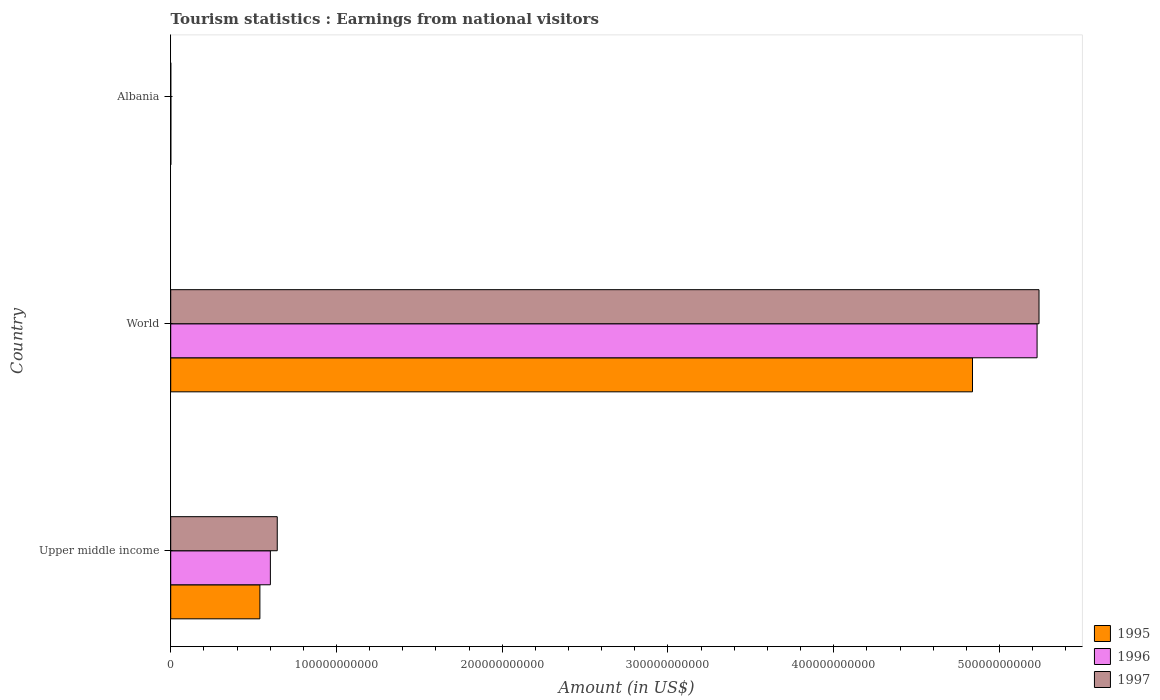Are the number of bars per tick equal to the number of legend labels?
Provide a short and direct response. Yes. Are the number of bars on each tick of the Y-axis equal?
Keep it short and to the point. Yes. How many bars are there on the 2nd tick from the bottom?
Your answer should be very brief. 3. What is the label of the 3rd group of bars from the top?
Provide a short and direct response. Upper middle income. What is the earnings from national visitors in 1997 in World?
Offer a very short reply. 5.24e+11. Across all countries, what is the maximum earnings from national visitors in 1995?
Your response must be concise. 4.84e+11. Across all countries, what is the minimum earnings from national visitors in 1995?
Offer a terse response. 7.04e+07. In which country was the earnings from national visitors in 1995 minimum?
Provide a short and direct response. Albania. What is the total earnings from national visitors in 1996 in the graph?
Keep it short and to the point. 5.83e+11. What is the difference between the earnings from national visitors in 1995 in Upper middle income and that in World?
Offer a terse response. -4.30e+11. What is the difference between the earnings from national visitors in 1995 in Upper middle income and the earnings from national visitors in 1997 in World?
Offer a terse response. -4.70e+11. What is the average earnings from national visitors in 1995 per country?
Offer a terse response. 1.79e+11. What is the difference between the earnings from national visitors in 1997 and earnings from national visitors in 1995 in Albania?
Your answer should be very brief. -3.68e+07. What is the ratio of the earnings from national visitors in 1995 in Albania to that in Upper middle income?
Ensure brevity in your answer.  0. Is the earnings from national visitors in 1995 in Albania less than that in Upper middle income?
Offer a terse response. Yes. Is the difference between the earnings from national visitors in 1997 in Upper middle income and World greater than the difference between the earnings from national visitors in 1995 in Upper middle income and World?
Keep it short and to the point. No. What is the difference between the highest and the second highest earnings from national visitors in 1997?
Your answer should be compact. 4.60e+11. What is the difference between the highest and the lowest earnings from national visitors in 1996?
Your answer should be compact. 5.23e+11. What does the 2nd bar from the bottom in Upper middle income represents?
Keep it short and to the point. 1996. Is it the case that in every country, the sum of the earnings from national visitors in 1995 and earnings from national visitors in 1996 is greater than the earnings from national visitors in 1997?
Provide a short and direct response. Yes. Are all the bars in the graph horizontal?
Make the answer very short. Yes. How many countries are there in the graph?
Your answer should be compact. 3. What is the difference between two consecutive major ticks on the X-axis?
Offer a very short reply. 1.00e+11. Does the graph contain any zero values?
Your answer should be compact. No. Does the graph contain grids?
Provide a succinct answer. No. How many legend labels are there?
Provide a succinct answer. 3. What is the title of the graph?
Keep it short and to the point. Tourism statistics : Earnings from national visitors. What is the Amount (in US$) of 1995 in Upper middle income?
Offer a very short reply. 5.38e+1. What is the Amount (in US$) in 1996 in Upper middle income?
Keep it short and to the point. 6.01e+1. What is the Amount (in US$) of 1997 in Upper middle income?
Make the answer very short. 6.43e+1. What is the Amount (in US$) of 1995 in World?
Give a very brief answer. 4.84e+11. What is the Amount (in US$) of 1996 in World?
Keep it short and to the point. 5.23e+11. What is the Amount (in US$) of 1997 in World?
Your response must be concise. 5.24e+11. What is the Amount (in US$) of 1995 in Albania?
Keep it short and to the point. 7.04e+07. What is the Amount (in US$) in 1996 in Albania?
Ensure brevity in your answer.  9.38e+07. What is the Amount (in US$) in 1997 in Albania?
Provide a short and direct response. 3.36e+07. Across all countries, what is the maximum Amount (in US$) in 1995?
Provide a short and direct response. 4.84e+11. Across all countries, what is the maximum Amount (in US$) of 1996?
Make the answer very short. 5.23e+11. Across all countries, what is the maximum Amount (in US$) of 1997?
Keep it short and to the point. 5.24e+11. Across all countries, what is the minimum Amount (in US$) of 1995?
Your response must be concise. 7.04e+07. Across all countries, what is the minimum Amount (in US$) of 1996?
Your answer should be very brief. 9.38e+07. Across all countries, what is the minimum Amount (in US$) in 1997?
Offer a terse response. 3.36e+07. What is the total Amount (in US$) in 1995 in the graph?
Keep it short and to the point. 5.38e+11. What is the total Amount (in US$) in 1996 in the graph?
Your answer should be compact. 5.83e+11. What is the total Amount (in US$) of 1997 in the graph?
Your response must be concise. 5.88e+11. What is the difference between the Amount (in US$) of 1995 in Upper middle income and that in World?
Make the answer very short. -4.30e+11. What is the difference between the Amount (in US$) in 1996 in Upper middle income and that in World?
Your answer should be compact. -4.63e+11. What is the difference between the Amount (in US$) of 1997 in Upper middle income and that in World?
Ensure brevity in your answer.  -4.60e+11. What is the difference between the Amount (in US$) of 1995 in Upper middle income and that in Albania?
Make the answer very short. 5.37e+1. What is the difference between the Amount (in US$) of 1996 in Upper middle income and that in Albania?
Give a very brief answer. 6.00e+1. What is the difference between the Amount (in US$) in 1997 in Upper middle income and that in Albania?
Make the answer very short. 6.42e+1. What is the difference between the Amount (in US$) in 1995 in World and that in Albania?
Provide a short and direct response. 4.84e+11. What is the difference between the Amount (in US$) in 1996 in World and that in Albania?
Your response must be concise. 5.23e+11. What is the difference between the Amount (in US$) of 1997 in World and that in Albania?
Keep it short and to the point. 5.24e+11. What is the difference between the Amount (in US$) of 1995 in Upper middle income and the Amount (in US$) of 1996 in World?
Give a very brief answer. -4.69e+11. What is the difference between the Amount (in US$) in 1995 in Upper middle income and the Amount (in US$) in 1997 in World?
Keep it short and to the point. -4.70e+11. What is the difference between the Amount (in US$) in 1996 in Upper middle income and the Amount (in US$) in 1997 in World?
Ensure brevity in your answer.  -4.64e+11. What is the difference between the Amount (in US$) of 1995 in Upper middle income and the Amount (in US$) of 1996 in Albania?
Provide a short and direct response. 5.37e+1. What is the difference between the Amount (in US$) in 1995 in Upper middle income and the Amount (in US$) in 1997 in Albania?
Offer a terse response. 5.38e+1. What is the difference between the Amount (in US$) of 1996 in Upper middle income and the Amount (in US$) of 1997 in Albania?
Your answer should be very brief. 6.01e+1. What is the difference between the Amount (in US$) in 1995 in World and the Amount (in US$) in 1996 in Albania?
Your response must be concise. 4.84e+11. What is the difference between the Amount (in US$) in 1995 in World and the Amount (in US$) in 1997 in Albania?
Your answer should be compact. 4.84e+11. What is the difference between the Amount (in US$) in 1996 in World and the Amount (in US$) in 1997 in Albania?
Keep it short and to the point. 5.23e+11. What is the average Amount (in US$) in 1995 per country?
Give a very brief answer. 1.79e+11. What is the average Amount (in US$) in 1996 per country?
Offer a very short reply. 1.94e+11. What is the average Amount (in US$) in 1997 per country?
Your response must be concise. 1.96e+11. What is the difference between the Amount (in US$) of 1995 and Amount (in US$) of 1996 in Upper middle income?
Your answer should be compact. -6.33e+09. What is the difference between the Amount (in US$) of 1995 and Amount (in US$) of 1997 in Upper middle income?
Provide a short and direct response. -1.05e+1. What is the difference between the Amount (in US$) in 1996 and Amount (in US$) in 1997 in Upper middle income?
Make the answer very short. -4.15e+09. What is the difference between the Amount (in US$) in 1995 and Amount (in US$) in 1996 in World?
Your response must be concise. -3.90e+1. What is the difference between the Amount (in US$) of 1995 and Amount (in US$) of 1997 in World?
Your answer should be very brief. -4.01e+1. What is the difference between the Amount (in US$) of 1996 and Amount (in US$) of 1997 in World?
Ensure brevity in your answer.  -1.17e+09. What is the difference between the Amount (in US$) in 1995 and Amount (in US$) in 1996 in Albania?
Provide a short and direct response. -2.34e+07. What is the difference between the Amount (in US$) of 1995 and Amount (in US$) of 1997 in Albania?
Your response must be concise. 3.68e+07. What is the difference between the Amount (in US$) of 1996 and Amount (in US$) of 1997 in Albania?
Provide a succinct answer. 6.02e+07. What is the ratio of the Amount (in US$) in 1995 in Upper middle income to that in World?
Make the answer very short. 0.11. What is the ratio of the Amount (in US$) of 1996 in Upper middle income to that in World?
Ensure brevity in your answer.  0.12. What is the ratio of the Amount (in US$) of 1997 in Upper middle income to that in World?
Make the answer very short. 0.12. What is the ratio of the Amount (in US$) of 1995 in Upper middle income to that in Albania?
Provide a short and direct response. 764.16. What is the ratio of the Amount (in US$) of 1996 in Upper middle income to that in Albania?
Give a very brief answer. 641.02. What is the ratio of the Amount (in US$) in 1997 in Upper middle income to that in Albania?
Provide a succinct answer. 1912.87. What is the ratio of the Amount (in US$) in 1995 in World to that in Albania?
Your answer should be compact. 6871.01. What is the ratio of the Amount (in US$) of 1996 in World to that in Albania?
Offer a terse response. 5572.3. What is the ratio of the Amount (in US$) of 1997 in World to that in Albania?
Provide a short and direct response. 1.56e+04. What is the difference between the highest and the second highest Amount (in US$) of 1995?
Your response must be concise. 4.30e+11. What is the difference between the highest and the second highest Amount (in US$) in 1996?
Your answer should be very brief. 4.63e+11. What is the difference between the highest and the second highest Amount (in US$) of 1997?
Your answer should be compact. 4.60e+11. What is the difference between the highest and the lowest Amount (in US$) of 1995?
Keep it short and to the point. 4.84e+11. What is the difference between the highest and the lowest Amount (in US$) of 1996?
Provide a succinct answer. 5.23e+11. What is the difference between the highest and the lowest Amount (in US$) in 1997?
Offer a very short reply. 5.24e+11. 